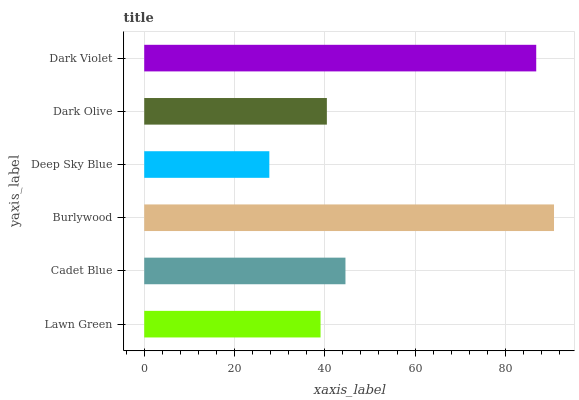Is Deep Sky Blue the minimum?
Answer yes or no. Yes. Is Burlywood the maximum?
Answer yes or no. Yes. Is Cadet Blue the minimum?
Answer yes or no. No. Is Cadet Blue the maximum?
Answer yes or no. No. Is Cadet Blue greater than Lawn Green?
Answer yes or no. Yes. Is Lawn Green less than Cadet Blue?
Answer yes or no. Yes. Is Lawn Green greater than Cadet Blue?
Answer yes or no. No. Is Cadet Blue less than Lawn Green?
Answer yes or no. No. Is Cadet Blue the high median?
Answer yes or no. Yes. Is Dark Olive the low median?
Answer yes or no. Yes. Is Dark Olive the high median?
Answer yes or no. No. Is Burlywood the low median?
Answer yes or no. No. 